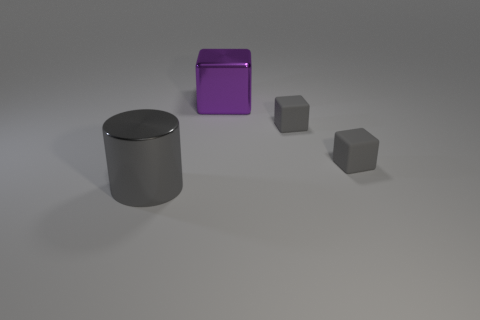Is there a matte thing that has the same color as the cylinder?
Your answer should be compact. Yes. There is a large gray thing; is its shape the same as the big metal thing that is on the right side of the cylinder?
Give a very brief answer. No. What number of gray things are on the left side of the big purple object and to the right of the big cylinder?
Offer a terse response. 0. What size is the metallic thing that is right of the large cylinder that is left of the metallic cube?
Provide a short and direct response. Large. Are there any yellow things?
Provide a short and direct response. No. Is the number of metal things left of the large metallic cube greater than the number of tiny rubber blocks in front of the large cylinder?
Provide a short and direct response. Yes. Are there any gray cylinders of the same size as the purple thing?
Keep it short and to the point. Yes. There is a metallic thing that is in front of the metallic object behind the large thing that is in front of the big purple cube; what is its size?
Your response must be concise. Large. The large cube is what color?
Your response must be concise. Purple. Is the number of large metallic cylinders to the right of the big gray thing greater than the number of shiny cylinders?
Make the answer very short. No. 